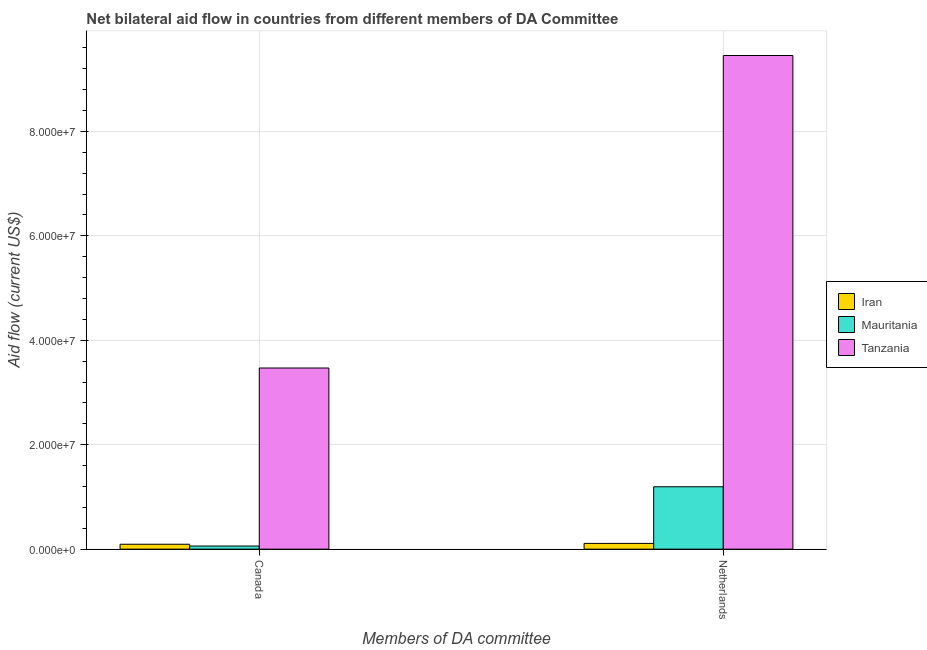How many different coloured bars are there?
Provide a succinct answer. 3. Are the number of bars on each tick of the X-axis equal?
Offer a very short reply. Yes. How many bars are there on the 1st tick from the left?
Offer a terse response. 3. What is the label of the 2nd group of bars from the left?
Ensure brevity in your answer.  Netherlands. What is the amount of aid given by netherlands in Tanzania?
Your answer should be compact. 9.45e+07. Across all countries, what is the maximum amount of aid given by canada?
Give a very brief answer. 3.47e+07. Across all countries, what is the minimum amount of aid given by canada?
Offer a very short reply. 6.00e+05. In which country was the amount of aid given by netherlands maximum?
Your answer should be very brief. Tanzania. In which country was the amount of aid given by netherlands minimum?
Your answer should be very brief. Iran. What is the total amount of aid given by canada in the graph?
Offer a terse response. 3.62e+07. What is the difference between the amount of aid given by netherlands in Mauritania and that in Tanzania?
Offer a very short reply. -8.26e+07. What is the difference between the amount of aid given by netherlands in Iran and the amount of aid given by canada in Mauritania?
Provide a short and direct response. 5.00e+05. What is the average amount of aid given by canada per country?
Provide a short and direct response. 1.21e+07. What is the difference between the amount of aid given by netherlands and amount of aid given by canada in Iran?
Your answer should be very brief. 1.60e+05. In how many countries, is the amount of aid given by canada greater than 68000000 US$?
Provide a succinct answer. 0. What is the ratio of the amount of aid given by canada in Mauritania to that in Iran?
Give a very brief answer. 0.64. In how many countries, is the amount of aid given by canada greater than the average amount of aid given by canada taken over all countries?
Provide a short and direct response. 1. What does the 3rd bar from the left in Netherlands represents?
Offer a terse response. Tanzania. What does the 1st bar from the right in Canada represents?
Offer a very short reply. Tanzania. How many bars are there?
Provide a short and direct response. 6. How many countries are there in the graph?
Make the answer very short. 3. Are the values on the major ticks of Y-axis written in scientific E-notation?
Give a very brief answer. Yes. Where does the legend appear in the graph?
Give a very brief answer. Center right. How are the legend labels stacked?
Your response must be concise. Vertical. What is the title of the graph?
Your response must be concise. Net bilateral aid flow in countries from different members of DA Committee. Does "Sierra Leone" appear as one of the legend labels in the graph?
Keep it short and to the point. No. What is the label or title of the X-axis?
Offer a very short reply. Members of DA committee. What is the Aid flow (current US$) in Iran in Canada?
Give a very brief answer. 9.40e+05. What is the Aid flow (current US$) in Mauritania in Canada?
Give a very brief answer. 6.00e+05. What is the Aid flow (current US$) in Tanzania in Canada?
Offer a very short reply. 3.47e+07. What is the Aid flow (current US$) in Iran in Netherlands?
Offer a terse response. 1.10e+06. What is the Aid flow (current US$) of Mauritania in Netherlands?
Offer a terse response. 1.20e+07. What is the Aid flow (current US$) in Tanzania in Netherlands?
Your answer should be compact. 9.45e+07. Across all Members of DA committee, what is the maximum Aid flow (current US$) of Iran?
Your answer should be very brief. 1.10e+06. Across all Members of DA committee, what is the maximum Aid flow (current US$) in Mauritania?
Make the answer very short. 1.20e+07. Across all Members of DA committee, what is the maximum Aid flow (current US$) in Tanzania?
Offer a very short reply. 9.45e+07. Across all Members of DA committee, what is the minimum Aid flow (current US$) in Iran?
Give a very brief answer. 9.40e+05. Across all Members of DA committee, what is the minimum Aid flow (current US$) in Tanzania?
Give a very brief answer. 3.47e+07. What is the total Aid flow (current US$) in Iran in the graph?
Offer a terse response. 2.04e+06. What is the total Aid flow (current US$) of Mauritania in the graph?
Offer a terse response. 1.26e+07. What is the total Aid flow (current US$) of Tanzania in the graph?
Make the answer very short. 1.29e+08. What is the difference between the Aid flow (current US$) in Iran in Canada and that in Netherlands?
Your response must be concise. -1.60e+05. What is the difference between the Aid flow (current US$) of Mauritania in Canada and that in Netherlands?
Your response must be concise. -1.14e+07. What is the difference between the Aid flow (current US$) of Tanzania in Canada and that in Netherlands?
Offer a terse response. -5.98e+07. What is the difference between the Aid flow (current US$) in Iran in Canada and the Aid flow (current US$) in Mauritania in Netherlands?
Your answer should be compact. -1.10e+07. What is the difference between the Aid flow (current US$) in Iran in Canada and the Aid flow (current US$) in Tanzania in Netherlands?
Offer a terse response. -9.36e+07. What is the difference between the Aid flow (current US$) of Mauritania in Canada and the Aid flow (current US$) of Tanzania in Netherlands?
Provide a succinct answer. -9.39e+07. What is the average Aid flow (current US$) in Iran per Members of DA committee?
Your answer should be compact. 1.02e+06. What is the average Aid flow (current US$) of Mauritania per Members of DA committee?
Give a very brief answer. 6.28e+06. What is the average Aid flow (current US$) in Tanzania per Members of DA committee?
Keep it short and to the point. 6.46e+07. What is the difference between the Aid flow (current US$) in Iran and Aid flow (current US$) in Tanzania in Canada?
Give a very brief answer. -3.38e+07. What is the difference between the Aid flow (current US$) in Mauritania and Aid flow (current US$) in Tanzania in Canada?
Your answer should be very brief. -3.41e+07. What is the difference between the Aid flow (current US$) of Iran and Aid flow (current US$) of Mauritania in Netherlands?
Ensure brevity in your answer.  -1.08e+07. What is the difference between the Aid flow (current US$) in Iran and Aid flow (current US$) in Tanzania in Netherlands?
Ensure brevity in your answer.  -9.34e+07. What is the difference between the Aid flow (current US$) of Mauritania and Aid flow (current US$) of Tanzania in Netherlands?
Ensure brevity in your answer.  -8.26e+07. What is the ratio of the Aid flow (current US$) of Iran in Canada to that in Netherlands?
Keep it short and to the point. 0.85. What is the ratio of the Aid flow (current US$) of Mauritania in Canada to that in Netherlands?
Ensure brevity in your answer.  0.05. What is the ratio of the Aid flow (current US$) in Tanzania in Canada to that in Netherlands?
Ensure brevity in your answer.  0.37. What is the difference between the highest and the second highest Aid flow (current US$) in Mauritania?
Ensure brevity in your answer.  1.14e+07. What is the difference between the highest and the second highest Aid flow (current US$) of Tanzania?
Offer a very short reply. 5.98e+07. What is the difference between the highest and the lowest Aid flow (current US$) in Iran?
Give a very brief answer. 1.60e+05. What is the difference between the highest and the lowest Aid flow (current US$) in Mauritania?
Offer a very short reply. 1.14e+07. What is the difference between the highest and the lowest Aid flow (current US$) in Tanzania?
Ensure brevity in your answer.  5.98e+07. 